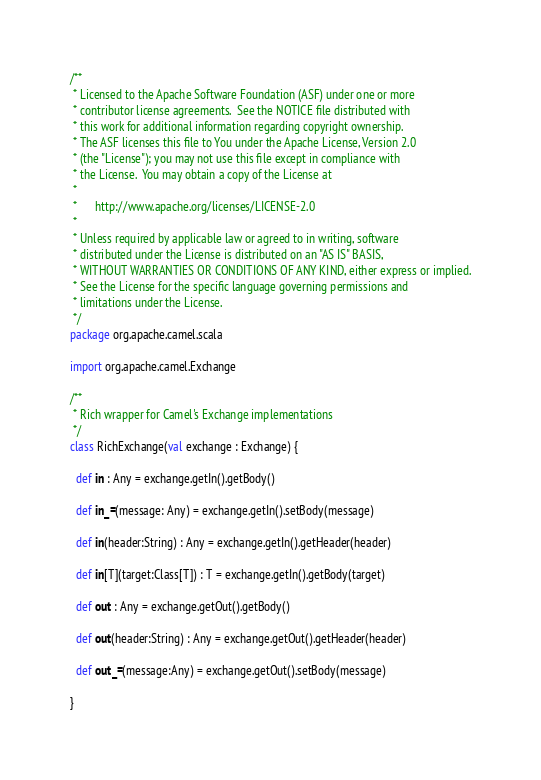<code> <loc_0><loc_0><loc_500><loc_500><_Scala_>/**
 * Licensed to the Apache Software Foundation (ASF) under one or more
 * contributor license agreements.  See the NOTICE file distributed with
 * this work for additional information regarding copyright ownership.
 * The ASF licenses this file to You under the Apache License, Version 2.0
 * (the "License"); you may not use this file except in compliance with
 * the License.  You may obtain a copy of the License at
 *
 *      http://www.apache.org/licenses/LICENSE-2.0
 *
 * Unless required by applicable law or agreed to in writing, software
 * distributed under the License is distributed on an "AS IS" BASIS,
 * WITHOUT WARRANTIES OR CONDITIONS OF ANY KIND, either express or implied.
 * See the License for the specific language governing permissions and
 * limitations under the License.
 */
package org.apache.camel.scala

import org.apache.camel.Exchange

/**
 * Rich wrapper for Camel's Exchange implementations
 */
class RichExchange(val exchange : Exchange) {

  def in : Any = exchange.getIn().getBody()
  
  def in_=(message: Any) = exchange.getIn().setBody(message)

  def in(header:String) : Any = exchange.getIn().getHeader(header)

  def in[T](target:Class[T]) : T = exchange.getIn().getBody(target)

  def out : Any = exchange.getOut().getBody()

  def out(header:String) : Any = exchange.getOut().getHeader(header)

  def out_=(message:Any) = exchange.getOut().setBody(message)

}
</code> 